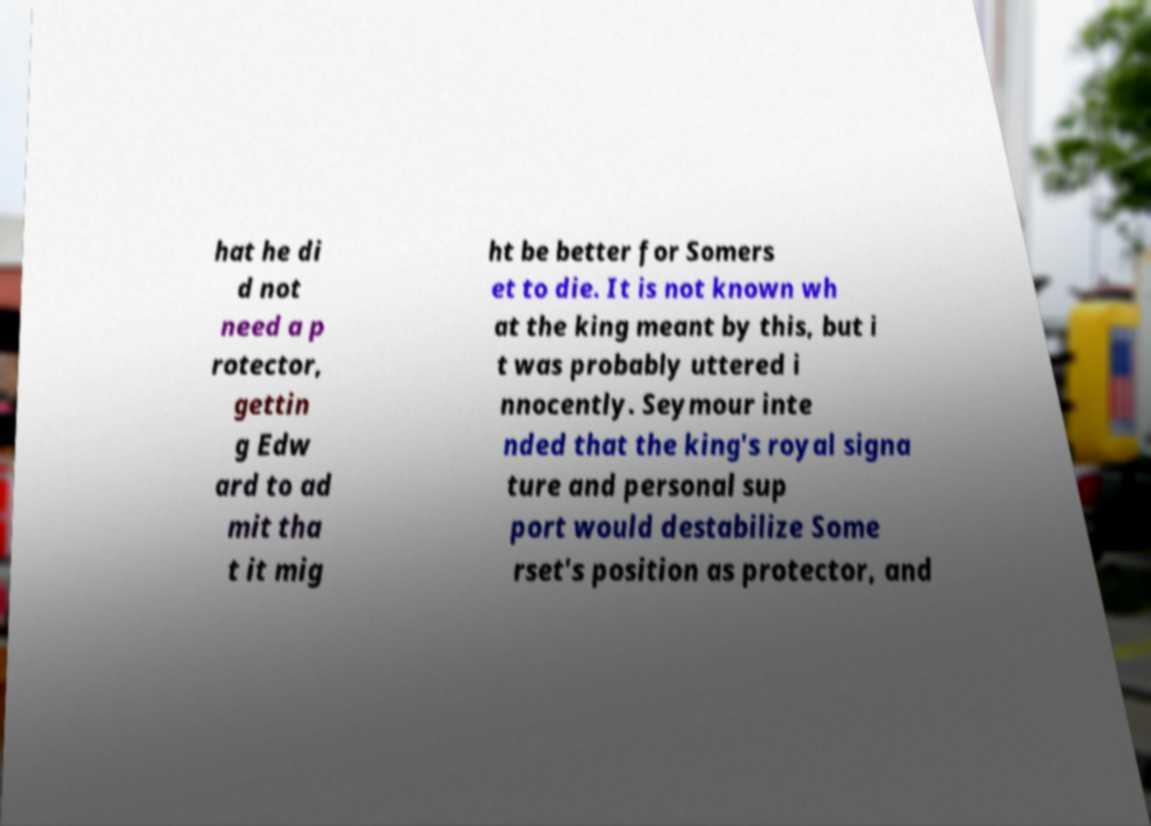I need the written content from this picture converted into text. Can you do that? hat he di d not need a p rotector, gettin g Edw ard to ad mit tha t it mig ht be better for Somers et to die. It is not known wh at the king meant by this, but i t was probably uttered i nnocently. Seymour inte nded that the king's royal signa ture and personal sup port would destabilize Some rset's position as protector, and 